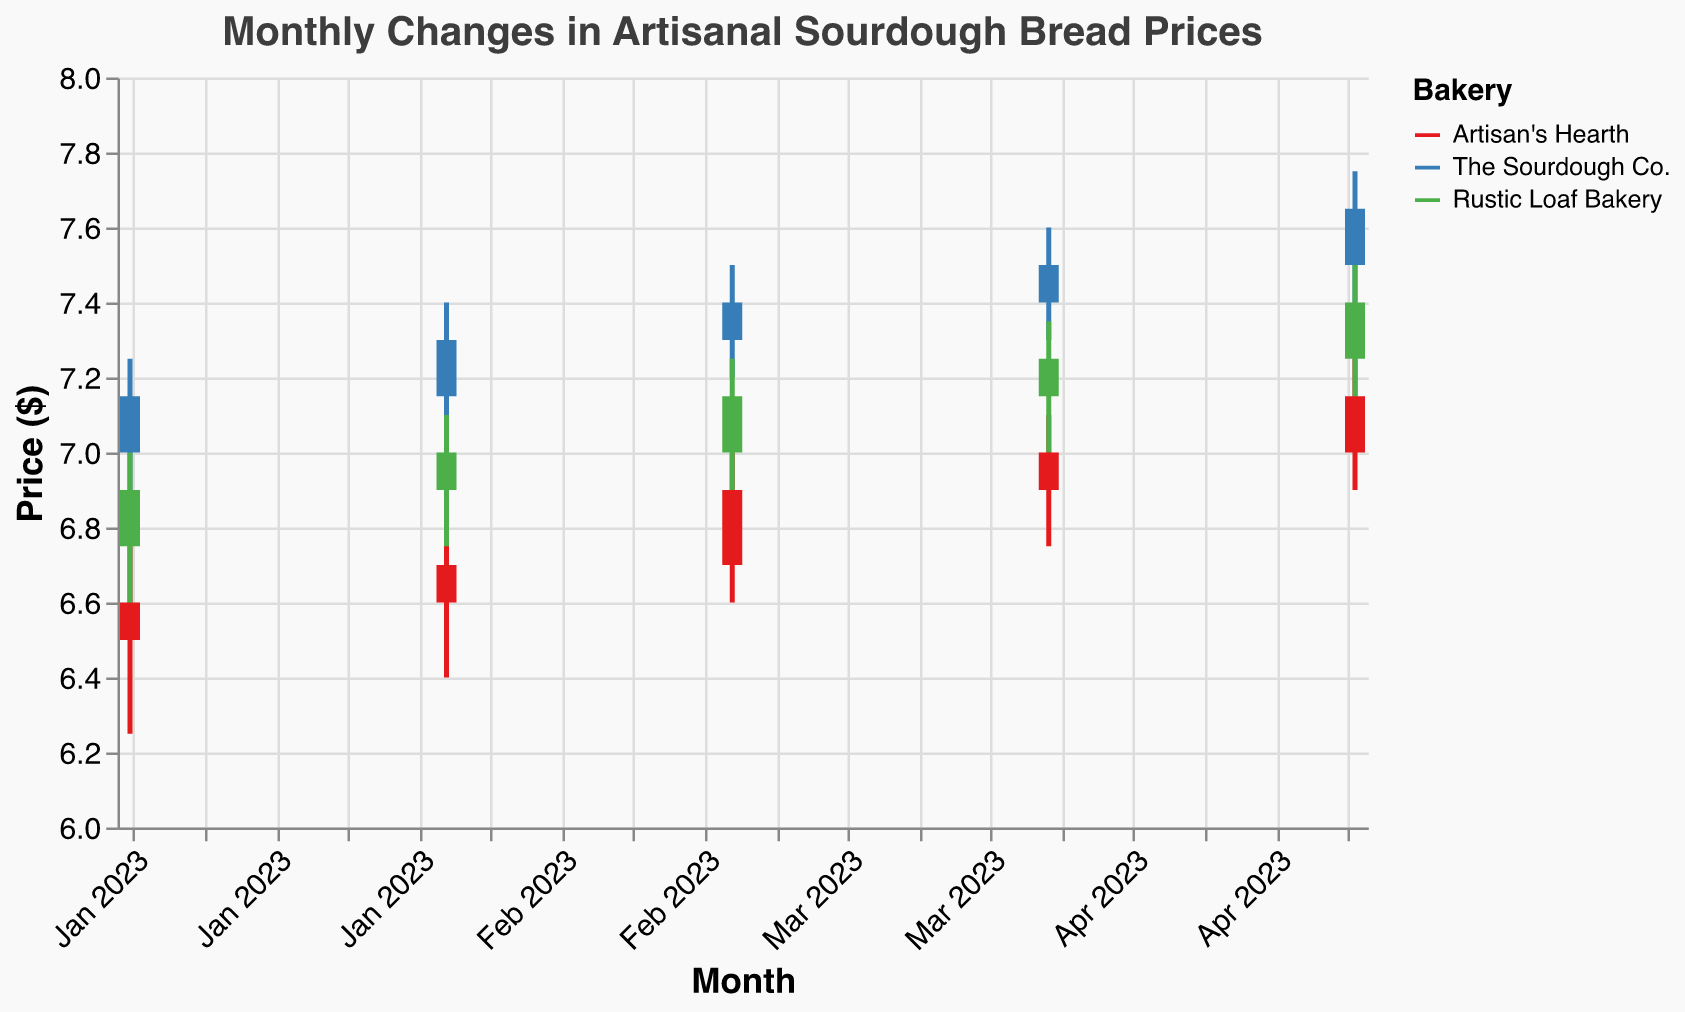How does the price of sourdough bread from Artisan's Hearth change from January to May 2023? The open price in January is $6.50 and the close price in May is $7.15. The increase is calculated by subtracting the January price from the May price: $7.15 - $6.50 = $0.65
Answer: $0.65 Which bakery had the highest closing price in May 2023? In May 2023, the closing prices for Artisan's Hearth, The Sourdough Co., and Rustic Loaf Bakery are $7.15, $7.65, and $7.40, respectively. The Sourdough Co. has the highest closing price at $7.65
Answer: The Sourdough Co What was the lowest price recorded for Rustic Loaf Bakery in February 2023? According to the data, the lowest price for Rustic Loaf Bakery in February 2023 is $6.75
Answer: $6.75 By how much did the price at Artisan's Hearth increase from March to April 2023? The closing price for Artisan's Hearth in March is $6.90 and in April is $7.00. The increase is calculated as $7.00 - $6.90 = $0.10
Answer: $0.10 Which bakery had the smallest range of prices in April 2023? The ranges are calculated as (High - Low) for each bakery. Artisan's Hearth: $7.10 - $6.75 = $0.35, The Sourdough Co.: $7.60 - $7.30 = $0.30, Rustic Loaf Bakery: $7.35 - $7.00 = $0.35. The smallest range is for The Sourdough Co. at $0.30
Answer: The Sourdough Co Were there any months where all bakeries had an increasing closing price from the previous month? Comparing each month to the previous month shows:
- Feb vs. Jan: All bakeries had increased closing prices.
- Mar vs. Feb: All bakeries had increased closing prices.
- Apr vs. Mar: All bakeries had increased closing prices.
- May vs. Apr: All bakeries had increased closing prices.
Hence, in all months from February to May, all bakeries had increasing closing prices.
Answer: Yes 